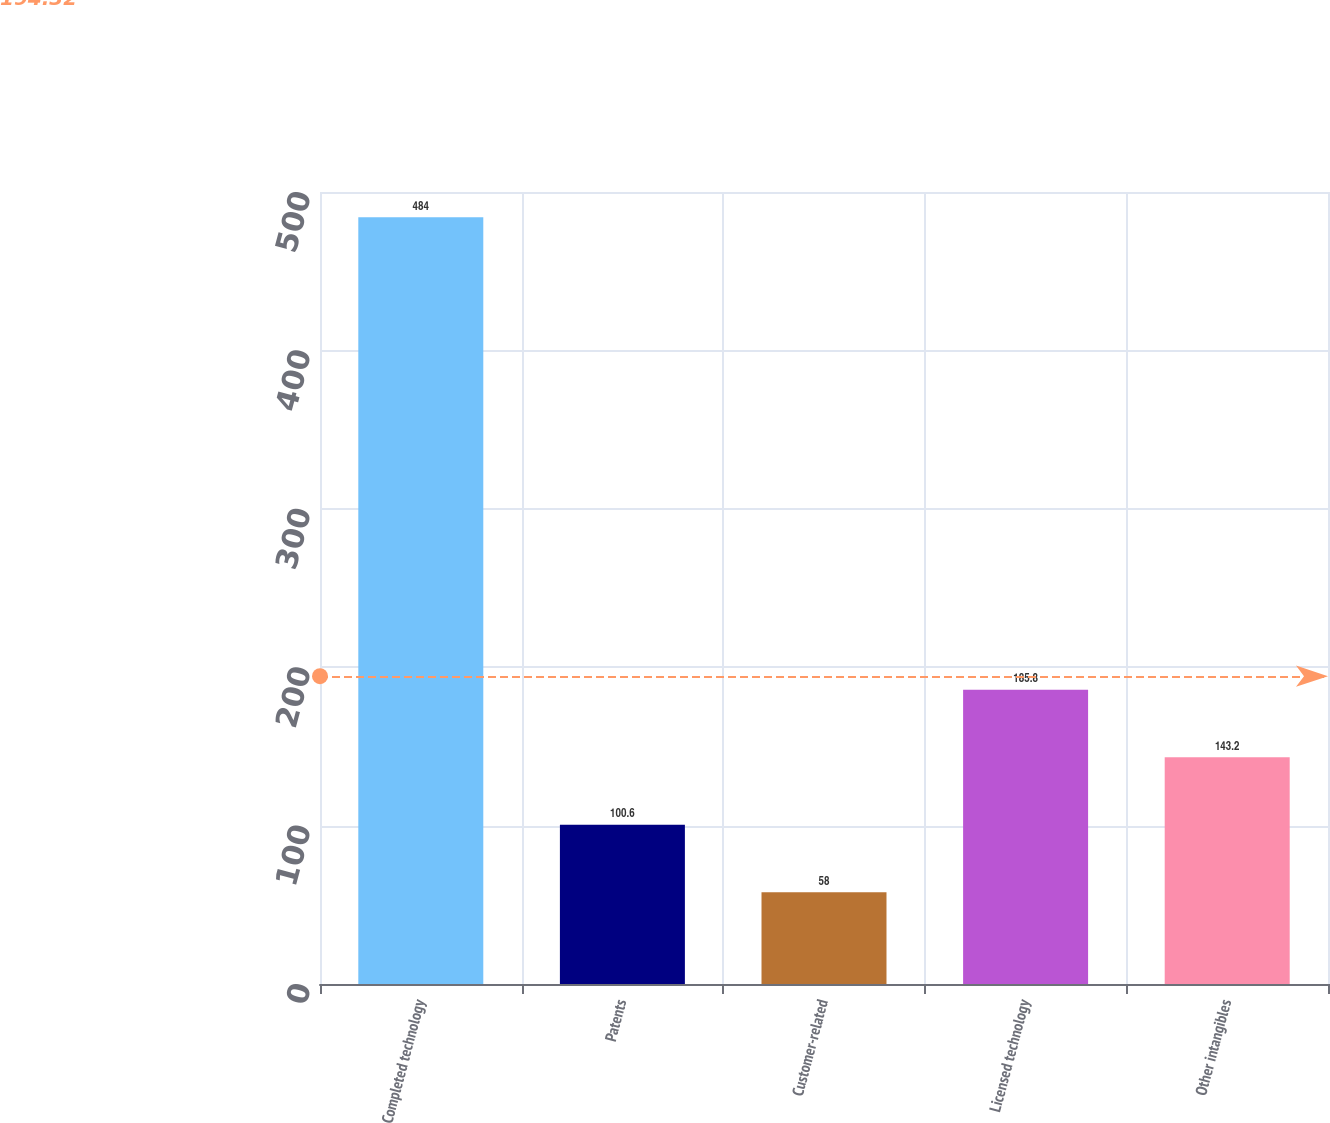Convert chart to OTSL. <chart><loc_0><loc_0><loc_500><loc_500><bar_chart><fcel>Completed technology<fcel>Patents<fcel>Customer-related<fcel>Licensed technology<fcel>Other intangibles<nl><fcel>484<fcel>100.6<fcel>58<fcel>185.8<fcel>143.2<nl></chart> 